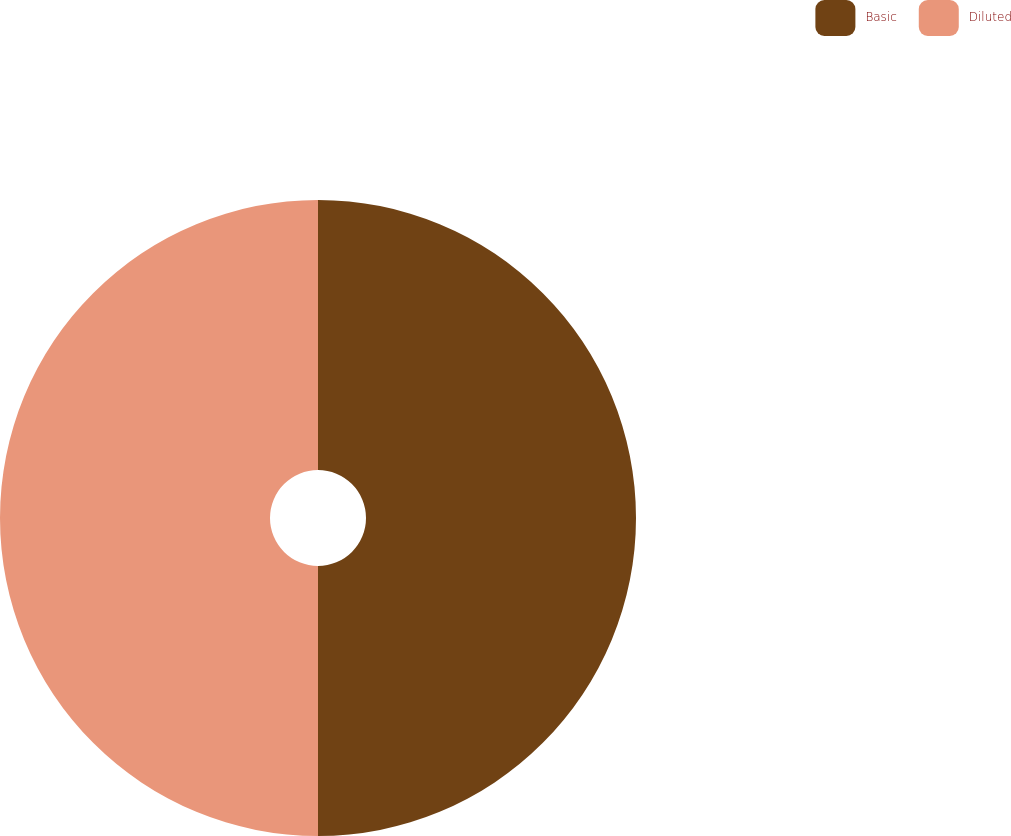Convert chart. <chart><loc_0><loc_0><loc_500><loc_500><pie_chart><fcel>Basic<fcel>Diluted<nl><fcel>50.0%<fcel>50.0%<nl></chart> 